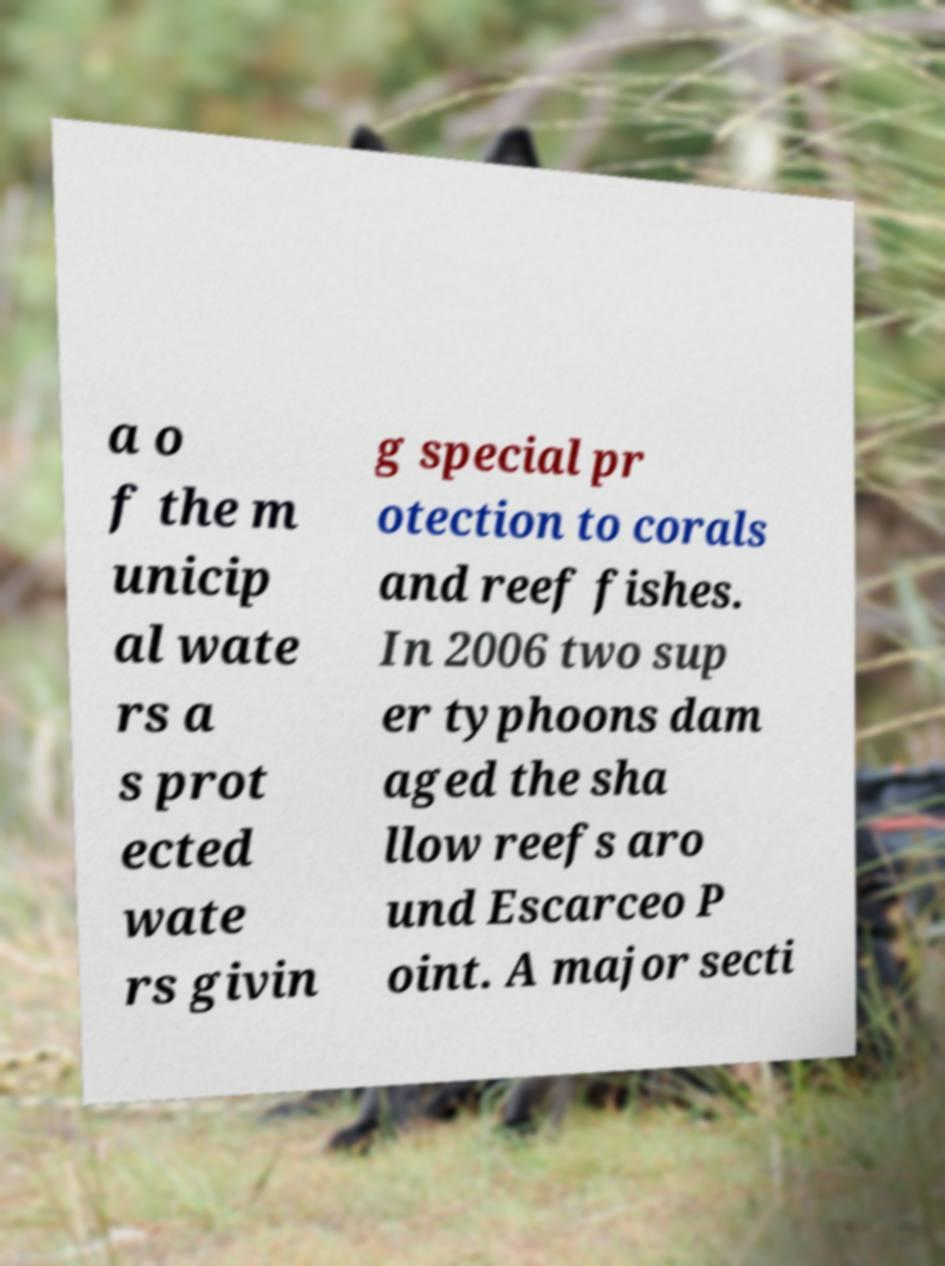For documentation purposes, I need the text within this image transcribed. Could you provide that? a o f the m unicip al wate rs a s prot ected wate rs givin g special pr otection to corals and reef fishes. In 2006 two sup er typhoons dam aged the sha llow reefs aro und Escarceo P oint. A major secti 